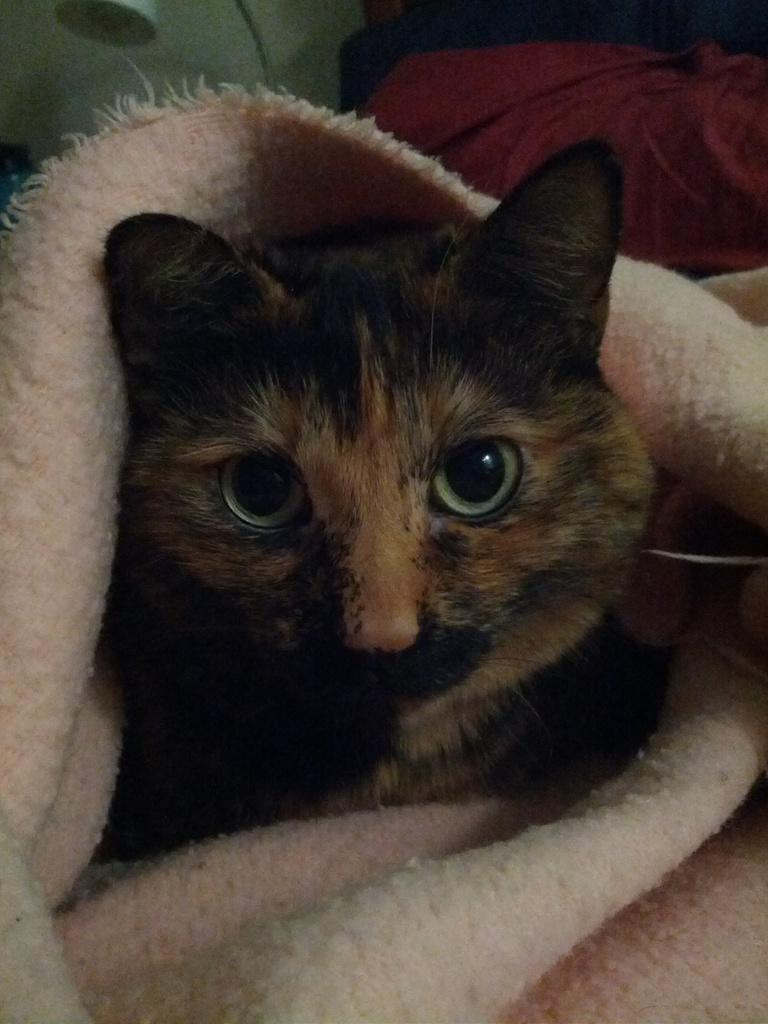What type of animal is in the image? There is a cat in the image. How is the cat positioned or situated in the image? The cat is in a blanket. What type of grain is visible in the image? There is no grain present in the image; it features a cat in a blanket. What attraction is the cat visiting in the image? There is no attraction present in the image; it features a cat in a blanket. 